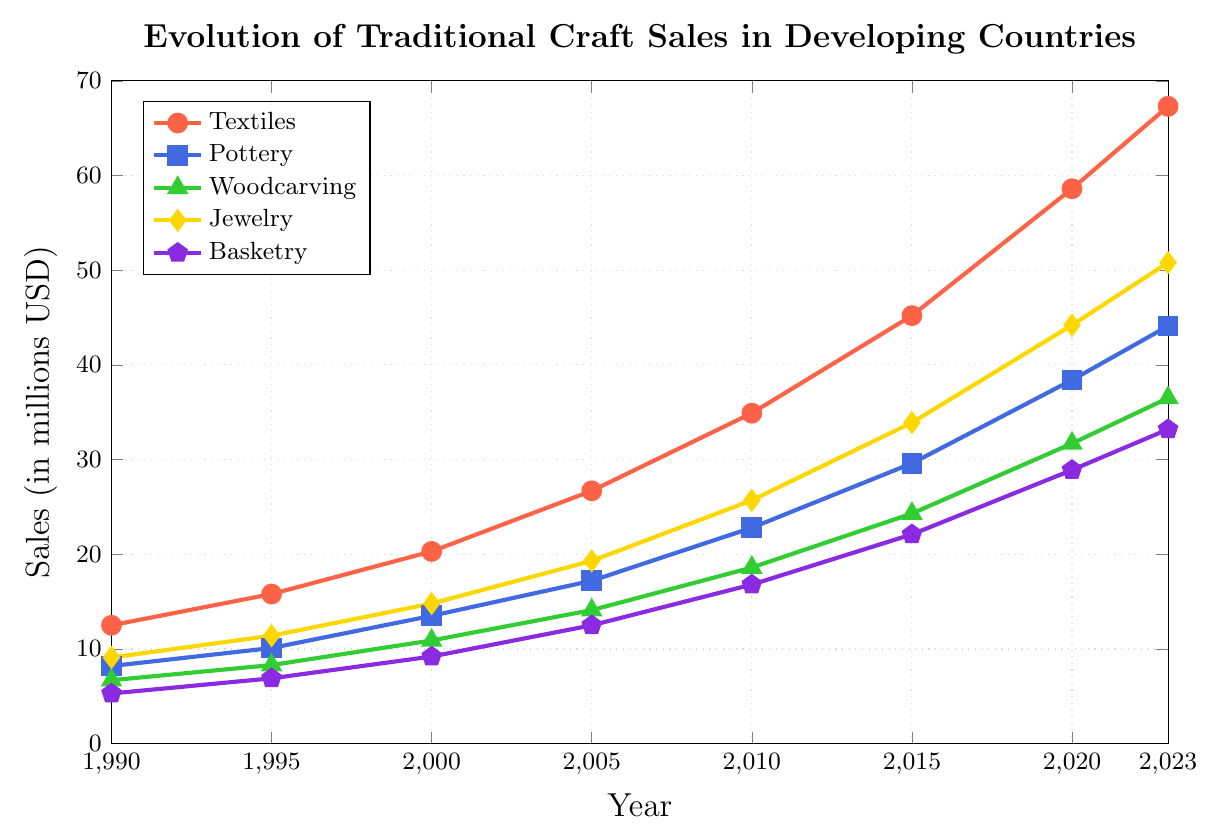Which craft category had the highest sales in 2023? First, identify the sales values for all categories in 2023, then compare them: Textiles (67.3), Pottery (44.1), Woodcarving (36.5), Jewelry (50.8), Basketry (33.2). Textiles have the highest value.
Answer: Textiles Which craft category showed the largest growth in sales from 1990 to 2023? Calculate the difference between the sales in 2023 and 1990 for each category: Textiles (67.3 - 12.5 = 54.8), Pottery (44.1 - 8.2 = 35.9), Woodcarving (36.5 - 6.7 = 29.8), Jewelry (50.8 - 9.1 = 41.7), Basketry (33.2 - 5.3 = 27.9). Textiles had the largest growth.
Answer: Textiles Which craft categories surpassed the sales of USD 30 million before 2015? Identify from the plot the years when categories surpassed USD 30 million: Textiles (before 2015), Pottery (by 2015), Woodcarving (by 2015), Jewelry (before 2015), Basketry (by 2020). Hence, Textiles, Jewelry, and Pottery surpassed before 2015.
Answer: Textiles, Jewelry, Pottery What is the average growth rate per year for Pottery from 1990 to 2023? Calculate the total growth for Pottery from 1990 to 2023: 44.1 - 8.2 = 35.9. Divide by the number of years: 2023 - 1990 = 33 years. So, the growth rate is 35.9 / 33 ≈ 1.09 million USD per year.
Answer: ≈ 1.09 million USD/year How does the growth trend of Basketry compare to Woodcarving from 2000 to 2023? Calculate the growth in sales from 2000 to 2023 for both categories: Basketry (33.2 - 9.2 = 24), Woodcarving (36.5 - 10.9 = 25.6). Both categories have similar growth trends, but Woodcarving slightly outpaced Basketry.
Answer: Woodcarving outpaced Basketry slightly Which craft category had the lowest sales in 1990, and what was the value? Look at the values for 1990: Textiles (12.5), Pottery (8.2), Woodcarving (6.7), Jewelry (9.1), Basketry (5.3). Basketry had the lowest sales.
Answer: Basketry, 5.3 million USD In 2010, how much more did textiles sell compared to basketry? Check the sales for Textiles and Basketry in 2010: Textiles (34.9), Basketry (16.8). Subtract Basketry sales from Textiles sales: 34.9 - 16.8 = 18.1 million USD.
Answer: 18.1 million USD If the trend continues, which craft is projected to exceed USD 60 million first after 2023? Observe the upward trends. Both Textiles and Jewelry are growing significantly, but Textiles already surpassing 60 million by 2023, implying it will continue to lead.
Answer: Textiles What is the total sales value of all craft categories combined in 2020? Sum the sales values for each category in 2020: 58.6 (Textiles) + 38.4 (Pottery) + 31.7 (Woodcarving) + 44.2 (Jewelry) + 28.9 (Basketry) = 201.8 million USD.
Answer: 201.8 million USD 